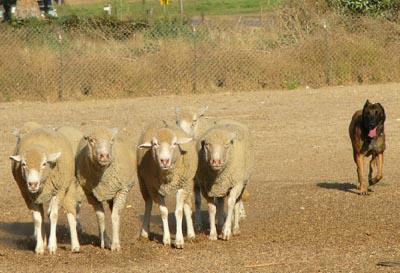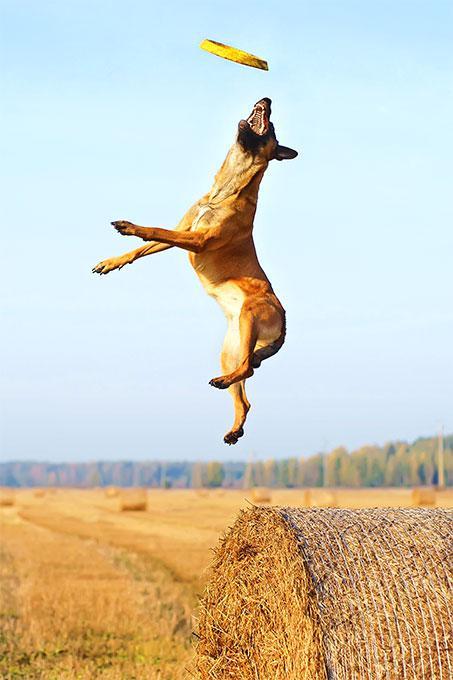The first image is the image on the left, the second image is the image on the right. Evaluate the accuracy of this statement regarding the images: "An image shows dogs posed on a wooden bench.". Is it true? Answer yes or no. No. 